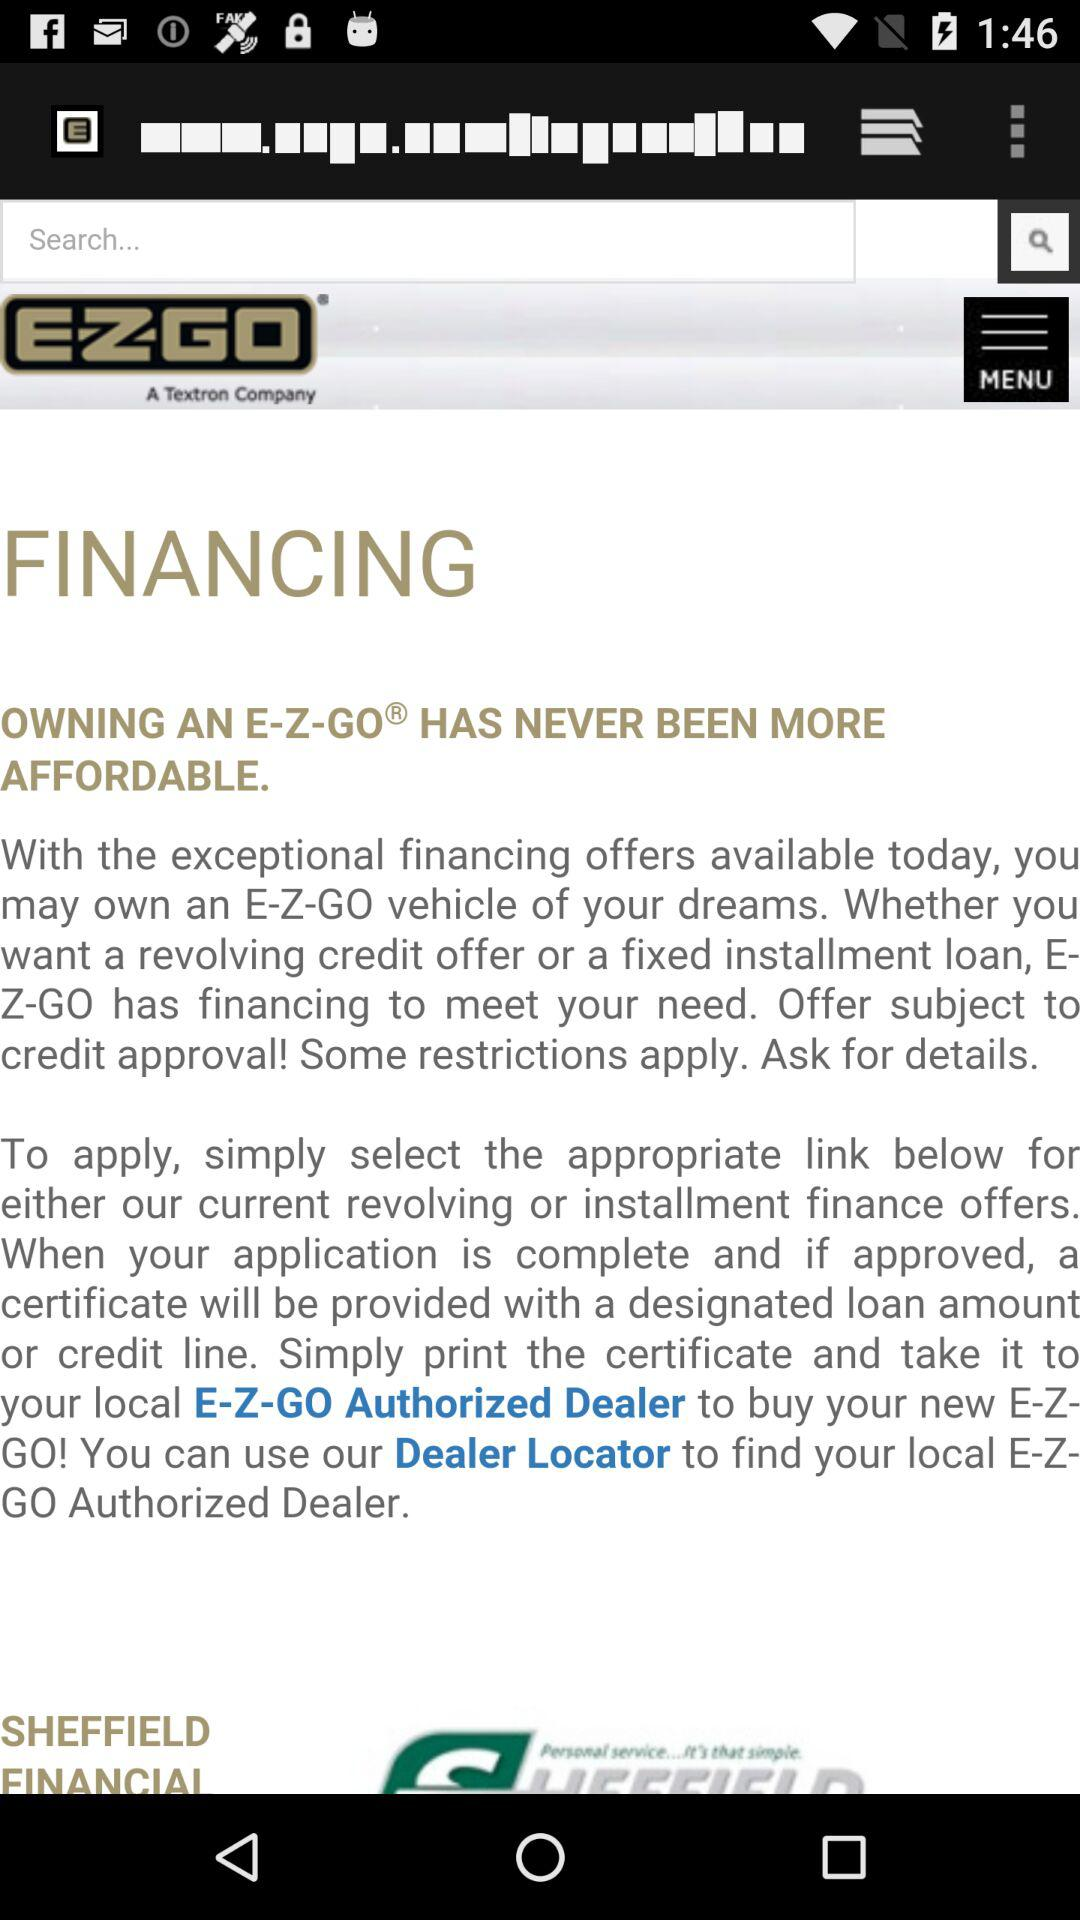What is the name of the company? The name of the company is "EZGO". 